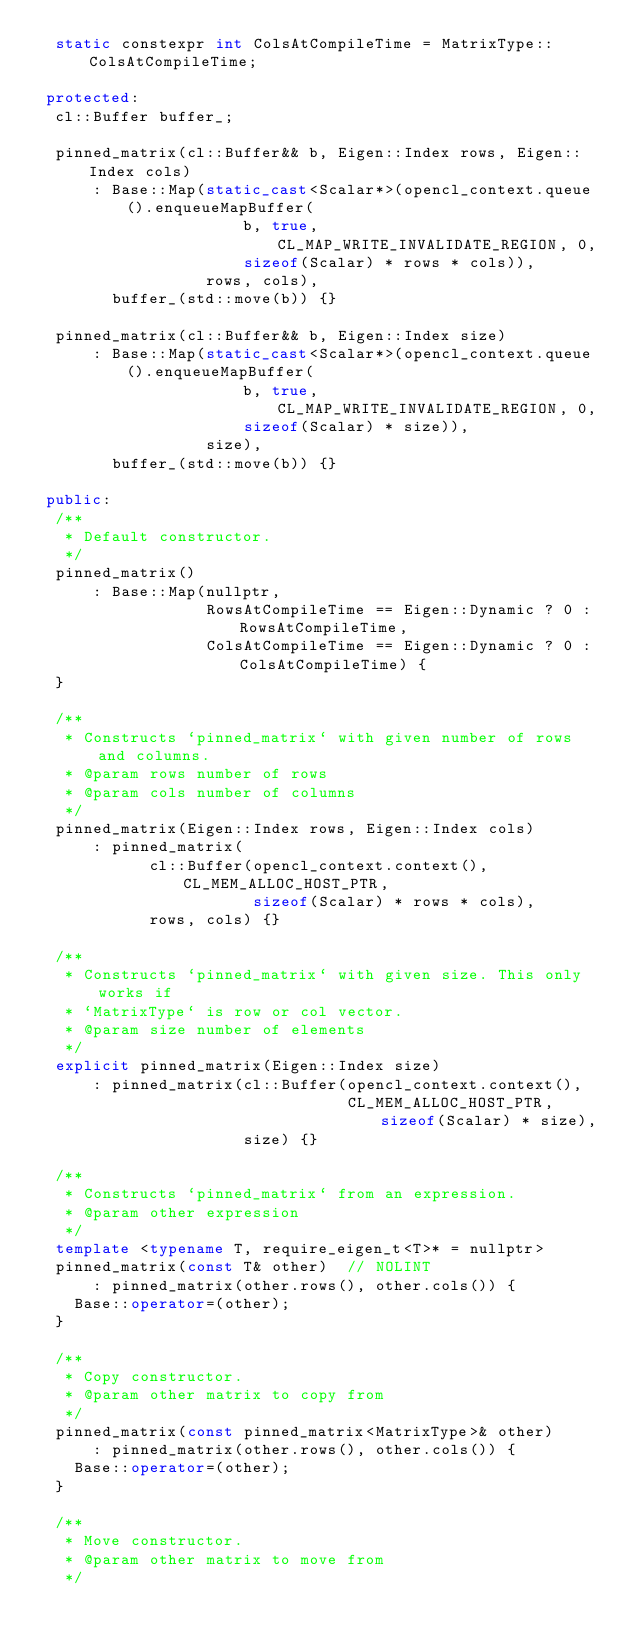Convert code to text. <code><loc_0><loc_0><loc_500><loc_500><_C++_>  static constexpr int ColsAtCompileTime = MatrixType::ColsAtCompileTime;

 protected:
  cl::Buffer buffer_;

  pinned_matrix(cl::Buffer&& b, Eigen::Index rows, Eigen::Index cols)
      : Base::Map(static_cast<Scalar*>(opencl_context.queue().enqueueMapBuffer(
                      b, true, CL_MAP_WRITE_INVALIDATE_REGION, 0,
                      sizeof(Scalar) * rows * cols)),
                  rows, cols),
        buffer_(std::move(b)) {}

  pinned_matrix(cl::Buffer&& b, Eigen::Index size)
      : Base::Map(static_cast<Scalar*>(opencl_context.queue().enqueueMapBuffer(
                      b, true, CL_MAP_WRITE_INVALIDATE_REGION, 0,
                      sizeof(Scalar) * size)),
                  size),
        buffer_(std::move(b)) {}

 public:
  /**
   * Default constructor.
   */
  pinned_matrix()
      : Base::Map(nullptr,
                  RowsAtCompileTime == Eigen::Dynamic ? 0 : RowsAtCompileTime,
                  ColsAtCompileTime == Eigen::Dynamic ? 0 : ColsAtCompileTime) {
  }

  /**
   * Constructs `pinned_matrix` with given number of rows and columns.
   * @param rows number of rows
   * @param cols number of columns
   */
  pinned_matrix(Eigen::Index rows, Eigen::Index cols)
      : pinned_matrix(
            cl::Buffer(opencl_context.context(), CL_MEM_ALLOC_HOST_PTR,
                       sizeof(Scalar) * rows * cols),
            rows, cols) {}

  /**
   * Constructs `pinned_matrix` with given size. This only works if
   * `MatrixType` is row or col vector.
   * @param size number of elements
   */
  explicit pinned_matrix(Eigen::Index size)
      : pinned_matrix(cl::Buffer(opencl_context.context(),
                                 CL_MEM_ALLOC_HOST_PTR, sizeof(Scalar) * size),
                      size) {}

  /**
   * Constructs `pinned_matrix` from an expression.
   * @param other expression
   */
  template <typename T, require_eigen_t<T>* = nullptr>
  pinned_matrix(const T& other)  // NOLINT
      : pinned_matrix(other.rows(), other.cols()) {
    Base::operator=(other);
  }

  /**
   * Copy constructor.
   * @param other matrix to copy from
   */
  pinned_matrix(const pinned_matrix<MatrixType>& other)
      : pinned_matrix(other.rows(), other.cols()) {
    Base::operator=(other);
  }

  /**
   * Move constructor.
   * @param other matrix to move from
   */</code> 